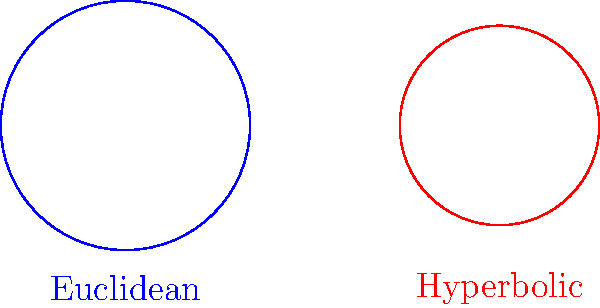As a Foreign Service Officer concerned about the safety of your relative working in a non-Euclidean environment, you're studying the differences between Euclidean and hyperbolic geometry. Consider two circles with the same radius $r$ in their respective geometries: one in Euclidean space and one in hyperbolic space (represented using the Klein model). If the area of the Euclidean circle is $\pi r^2$, what is the area of the hyperbolic circle in terms of $r$, given that the curvature $K$ of the hyperbolic plane is $-1$? To solve this problem, let's follow these steps:

1) In Euclidean geometry, the area of a circle with radius $r$ is:
   $$A_E = \pi r^2$$

2) In hyperbolic geometry with curvature $K=-1$, the area of a circle with radius $r$ is given by:
   $$A_H = 2\pi (\cosh r - 1)$$

3) We can expand this using the definition of cosh:
   $$A_H = 2\pi (\frac{e^r + e^{-r}}{2} - 1)$$

4) This can be simplified to:
   $$A_H = 2\pi (\frac{e^r - 2 + e^{-r}}{2})$$

5) For small values of $r$, we can use the Taylor expansion:
   $$e^r \approx 1 + r + \frac{r^2}{2} + \frac{r^3}{6} + ...$$
   $$e^{-r} \approx 1 - r + \frac{r^2}{2} - \frac{r^3}{6} + ...$$

6) Substituting these approximations:
   $$A_H \approx 2\pi (\frac{(1 + r + \frac{r^2}{2}) - 2 + (1 - r + \frac{r^2}{2})}{2})$$

7) Simplifying:
   $$A_H \approx 2\pi (\frac{r^2}{2}) = \pi r^2$$

8) This shows that for small $r$, the area of a hyperbolic circle approaches that of a Euclidean circle. However, for larger $r$, the hyperbolic area grows much faster than the Euclidean area.
Answer: $2\pi (\cosh r - 1)$ 